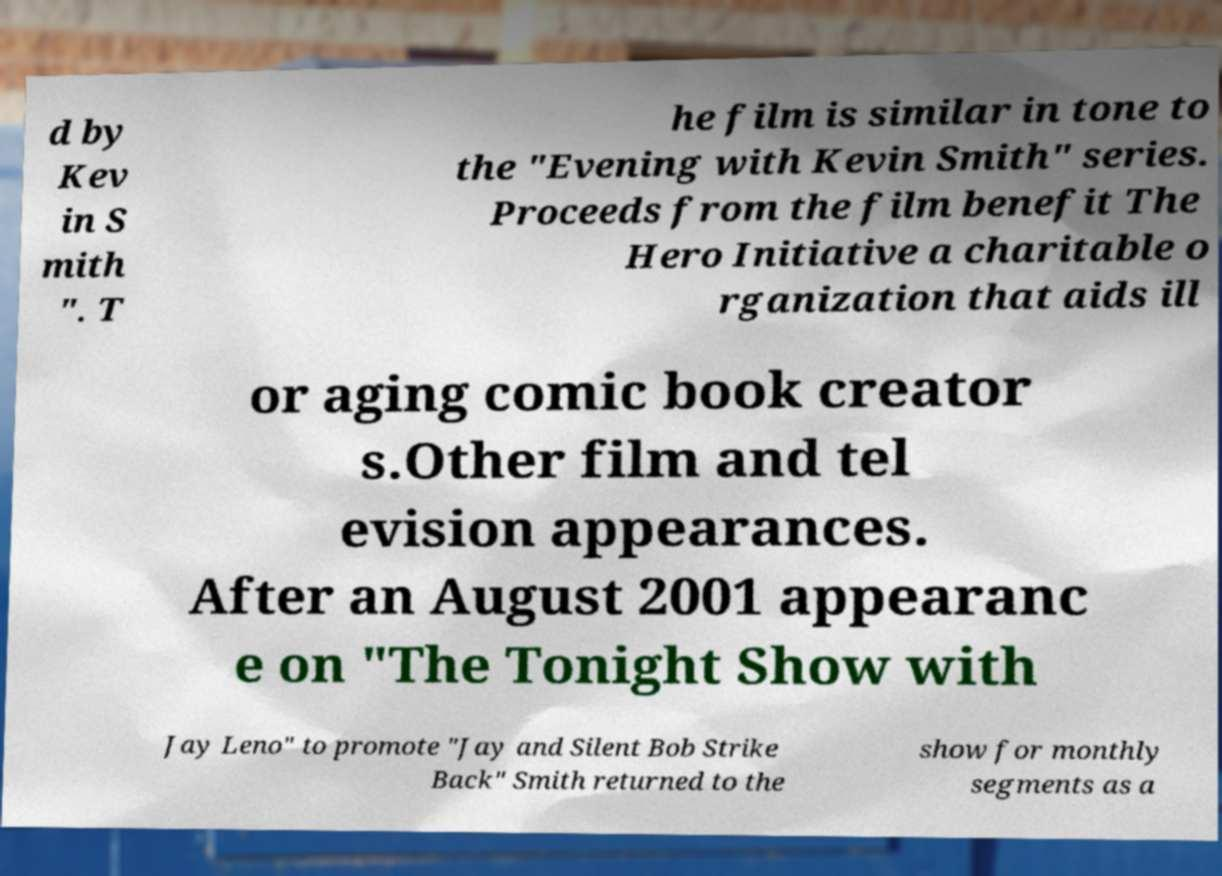Please read and relay the text visible in this image. What does it say? d by Kev in S mith ". T he film is similar in tone to the "Evening with Kevin Smith" series. Proceeds from the film benefit The Hero Initiative a charitable o rganization that aids ill or aging comic book creator s.Other film and tel evision appearances. After an August 2001 appearanc e on "The Tonight Show with Jay Leno" to promote "Jay and Silent Bob Strike Back" Smith returned to the show for monthly segments as a 